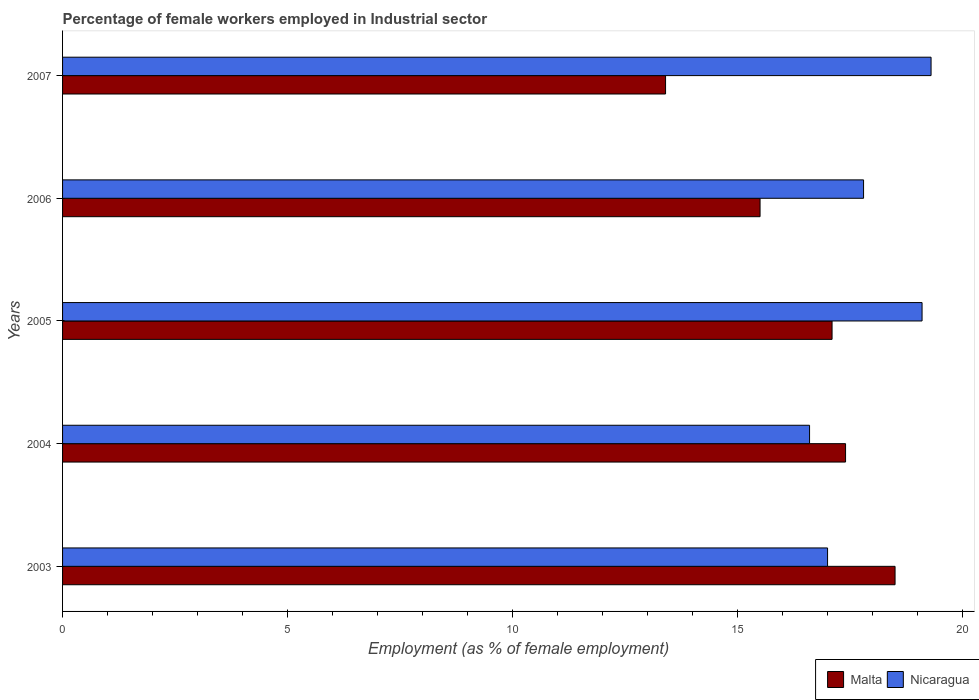How many different coloured bars are there?
Your answer should be compact. 2. How many groups of bars are there?
Ensure brevity in your answer.  5. Are the number of bars per tick equal to the number of legend labels?
Make the answer very short. Yes. Are the number of bars on each tick of the Y-axis equal?
Make the answer very short. Yes. How many bars are there on the 2nd tick from the top?
Your answer should be compact. 2. How many bars are there on the 2nd tick from the bottom?
Provide a short and direct response. 2. In how many cases, is the number of bars for a given year not equal to the number of legend labels?
Keep it short and to the point. 0. Across all years, what is the maximum percentage of females employed in Industrial sector in Nicaragua?
Your answer should be compact. 19.3. Across all years, what is the minimum percentage of females employed in Industrial sector in Malta?
Keep it short and to the point. 13.4. What is the total percentage of females employed in Industrial sector in Malta in the graph?
Give a very brief answer. 81.9. What is the difference between the percentage of females employed in Industrial sector in Nicaragua in 2003 and that in 2007?
Give a very brief answer. -2.3. What is the difference between the percentage of females employed in Industrial sector in Nicaragua in 2007 and the percentage of females employed in Industrial sector in Malta in 2003?
Keep it short and to the point. 0.8. What is the average percentage of females employed in Industrial sector in Nicaragua per year?
Offer a terse response. 17.96. What is the ratio of the percentage of females employed in Industrial sector in Nicaragua in 2003 to that in 2007?
Your answer should be compact. 0.88. Is the difference between the percentage of females employed in Industrial sector in Nicaragua in 2004 and 2005 greater than the difference between the percentage of females employed in Industrial sector in Malta in 2004 and 2005?
Make the answer very short. No. What is the difference between the highest and the second highest percentage of females employed in Industrial sector in Nicaragua?
Your response must be concise. 0.2. What is the difference between the highest and the lowest percentage of females employed in Industrial sector in Malta?
Keep it short and to the point. 5.1. What does the 1st bar from the top in 2006 represents?
Keep it short and to the point. Nicaragua. What does the 2nd bar from the bottom in 2007 represents?
Ensure brevity in your answer.  Nicaragua. How many bars are there?
Offer a very short reply. 10. Does the graph contain grids?
Provide a short and direct response. No. How many legend labels are there?
Keep it short and to the point. 2. What is the title of the graph?
Your answer should be very brief. Percentage of female workers employed in Industrial sector. What is the label or title of the X-axis?
Provide a short and direct response. Employment (as % of female employment). What is the label or title of the Y-axis?
Offer a terse response. Years. What is the Employment (as % of female employment) of Nicaragua in 2003?
Give a very brief answer. 17. What is the Employment (as % of female employment) of Malta in 2004?
Provide a short and direct response. 17.4. What is the Employment (as % of female employment) in Nicaragua in 2004?
Your response must be concise. 16.6. What is the Employment (as % of female employment) of Malta in 2005?
Give a very brief answer. 17.1. What is the Employment (as % of female employment) of Nicaragua in 2005?
Keep it short and to the point. 19.1. What is the Employment (as % of female employment) in Nicaragua in 2006?
Offer a terse response. 17.8. What is the Employment (as % of female employment) of Malta in 2007?
Provide a short and direct response. 13.4. What is the Employment (as % of female employment) of Nicaragua in 2007?
Give a very brief answer. 19.3. Across all years, what is the maximum Employment (as % of female employment) of Malta?
Make the answer very short. 18.5. Across all years, what is the maximum Employment (as % of female employment) of Nicaragua?
Your response must be concise. 19.3. Across all years, what is the minimum Employment (as % of female employment) of Malta?
Offer a terse response. 13.4. Across all years, what is the minimum Employment (as % of female employment) of Nicaragua?
Give a very brief answer. 16.6. What is the total Employment (as % of female employment) of Malta in the graph?
Your response must be concise. 81.9. What is the total Employment (as % of female employment) of Nicaragua in the graph?
Your answer should be very brief. 89.8. What is the difference between the Employment (as % of female employment) in Nicaragua in 2003 and that in 2004?
Your response must be concise. 0.4. What is the difference between the Employment (as % of female employment) in Malta in 2003 and that in 2005?
Ensure brevity in your answer.  1.4. What is the difference between the Employment (as % of female employment) in Malta in 2003 and that in 2006?
Provide a succinct answer. 3. What is the difference between the Employment (as % of female employment) in Malta in 2004 and that in 2005?
Your answer should be very brief. 0.3. What is the difference between the Employment (as % of female employment) in Nicaragua in 2004 and that in 2006?
Your answer should be very brief. -1.2. What is the difference between the Employment (as % of female employment) of Malta in 2004 and that in 2007?
Give a very brief answer. 4. What is the difference between the Employment (as % of female employment) of Nicaragua in 2005 and that in 2006?
Give a very brief answer. 1.3. What is the difference between the Employment (as % of female employment) in Malta in 2005 and that in 2007?
Make the answer very short. 3.7. What is the difference between the Employment (as % of female employment) of Nicaragua in 2006 and that in 2007?
Ensure brevity in your answer.  -1.5. What is the difference between the Employment (as % of female employment) in Malta in 2003 and the Employment (as % of female employment) in Nicaragua in 2005?
Make the answer very short. -0.6. What is the difference between the Employment (as % of female employment) in Malta in 2003 and the Employment (as % of female employment) in Nicaragua in 2006?
Provide a succinct answer. 0.7. What is the difference between the Employment (as % of female employment) of Malta in 2003 and the Employment (as % of female employment) of Nicaragua in 2007?
Ensure brevity in your answer.  -0.8. What is the difference between the Employment (as % of female employment) in Malta in 2004 and the Employment (as % of female employment) in Nicaragua in 2005?
Provide a short and direct response. -1.7. What is the difference between the Employment (as % of female employment) of Malta in 2004 and the Employment (as % of female employment) of Nicaragua in 2006?
Ensure brevity in your answer.  -0.4. What is the difference between the Employment (as % of female employment) in Malta in 2004 and the Employment (as % of female employment) in Nicaragua in 2007?
Your answer should be compact. -1.9. What is the difference between the Employment (as % of female employment) of Malta in 2005 and the Employment (as % of female employment) of Nicaragua in 2007?
Your answer should be compact. -2.2. What is the average Employment (as % of female employment) of Malta per year?
Offer a very short reply. 16.38. What is the average Employment (as % of female employment) of Nicaragua per year?
Your answer should be very brief. 17.96. In the year 2004, what is the difference between the Employment (as % of female employment) of Malta and Employment (as % of female employment) of Nicaragua?
Make the answer very short. 0.8. In the year 2006, what is the difference between the Employment (as % of female employment) in Malta and Employment (as % of female employment) in Nicaragua?
Your answer should be compact. -2.3. In the year 2007, what is the difference between the Employment (as % of female employment) in Malta and Employment (as % of female employment) in Nicaragua?
Your response must be concise. -5.9. What is the ratio of the Employment (as % of female employment) in Malta in 2003 to that in 2004?
Give a very brief answer. 1.06. What is the ratio of the Employment (as % of female employment) in Nicaragua in 2003 to that in 2004?
Keep it short and to the point. 1.02. What is the ratio of the Employment (as % of female employment) in Malta in 2003 to that in 2005?
Offer a very short reply. 1.08. What is the ratio of the Employment (as % of female employment) in Nicaragua in 2003 to that in 2005?
Your answer should be compact. 0.89. What is the ratio of the Employment (as % of female employment) of Malta in 2003 to that in 2006?
Provide a short and direct response. 1.19. What is the ratio of the Employment (as % of female employment) in Nicaragua in 2003 to that in 2006?
Your answer should be very brief. 0.96. What is the ratio of the Employment (as % of female employment) of Malta in 2003 to that in 2007?
Offer a very short reply. 1.38. What is the ratio of the Employment (as % of female employment) of Nicaragua in 2003 to that in 2007?
Offer a very short reply. 0.88. What is the ratio of the Employment (as % of female employment) of Malta in 2004 to that in 2005?
Keep it short and to the point. 1.02. What is the ratio of the Employment (as % of female employment) in Nicaragua in 2004 to that in 2005?
Offer a terse response. 0.87. What is the ratio of the Employment (as % of female employment) in Malta in 2004 to that in 2006?
Provide a short and direct response. 1.12. What is the ratio of the Employment (as % of female employment) in Nicaragua in 2004 to that in 2006?
Make the answer very short. 0.93. What is the ratio of the Employment (as % of female employment) of Malta in 2004 to that in 2007?
Keep it short and to the point. 1.3. What is the ratio of the Employment (as % of female employment) in Nicaragua in 2004 to that in 2007?
Keep it short and to the point. 0.86. What is the ratio of the Employment (as % of female employment) of Malta in 2005 to that in 2006?
Provide a short and direct response. 1.1. What is the ratio of the Employment (as % of female employment) of Nicaragua in 2005 to that in 2006?
Offer a terse response. 1.07. What is the ratio of the Employment (as % of female employment) of Malta in 2005 to that in 2007?
Make the answer very short. 1.28. What is the ratio of the Employment (as % of female employment) in Nicaragua in 2005 to that in 2007?
Give a very brief answer. 0.99. What is the ratio of the Employment (as % of female employment) in Malta in 2006 to that in 2007?
Your response must be concise. 1.16. What is the ratio of the Employment (as % of female employment) in Nicaragua in 2006 to that in 2007?
Give a very brief answer. 0.92. What is the difference between the highest and the second highest Employment (as % of female employment) of Malta?
Provide a succinct answer. 1.1. What is the difference between the highest and the second highest Employment (as % of female employment) in Nicaragua?
Your answer should be compact. 0.2. What is the difference between the highest and the lowest Employment (as % of female employment) of Malta?
Your response must be concise. 5.1. 